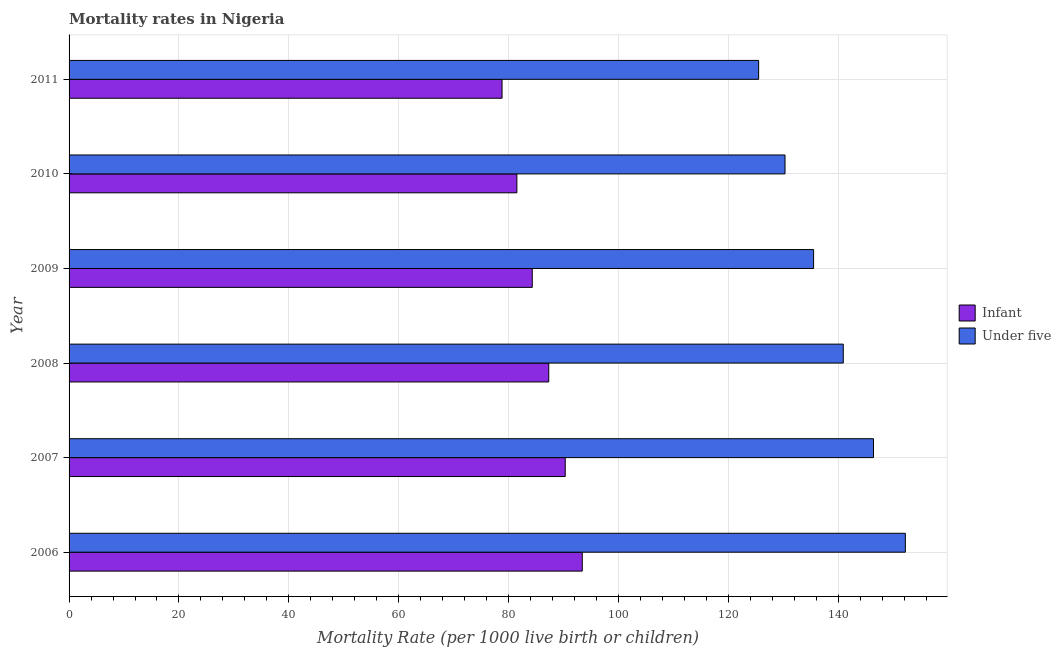How many different coloured bars are there?
Ensure brevity in your answer.  2. Are the number of bars per tick equal to the number of legend labels?
Provide a short and direct response. Yes. How many bars are there on the 1st tick from the top?
Your answer should be compact. 2. How many bars are there on the 4th tick from the bottom?
Offer a very short reply. 2. What is the label of the 6th group of bars from the top?
Ensure brevity in your answer.  2006. What is the infant mortality rate in 2007?
Keep it short and to the point. 90.3. Across all years, what is the maximum under-5 mortality rate?
Your response must be concise. 152.2. Across all years, what is the minimum infant mortality rate?
Make the answer very short. 78.8. What is the total infant mortality rate in the graph?
Your answer should be very brief. 515.6. What is the difference between the under-5 mortality rate in 2008 and that in 2009?
Offer a very short reply. 5.4. What is the difference between the under-5 mortality rate in 2008 and the infant mortality rate in 2011?
Provide a succinct answer. 62.1. What is the average infant mortality rate per year?
Your answer should be compact. 85.93. In the year 2011, what is the difference between the infant mortality rate and under-5 mortality rate?
Your answer should be compact. -46.7. In how many years, is the infant mortality rate greater than 104 ?
Offer a terse response. 0. What is the ratio of the infant mortality rate in 2006 to that in 2008?
Ensure brevity in your answer.  1.07. Is the under-5 mortality rate in 2008 less than that in 2009?
Keep it short and to the point. No. Is the difference between the infant mortality rate in 2006 and 2011 greater than the difference between the under-5 mortality rate in 2006 and 2011?
Offer a very short reply. No. What is the difference between the highest and the second highest infant mortality rate?
Give a very brief answer. 3.1. What is the difference between the highest and the lowest under-5 mortality rate?
Your answer should be very brief. 26.7. In how many years, is the under-5 mortality rate greater than the average under-5 mortality rate taken over all years?
Offer a very short reply. 3. Is the sum of the infant mortality rate in 2009 and 2010 greater than the maximum under-5 mortality rate across all years?
Ensure brevity in your answer.  Yes. What does the 2nd bar from the top in 2008 represents?
Provide a short and direct response. Infant. What does the 2nd bar from the bottom in 2010 represents?
Offer a very short reply. Under five. How many bars are there?
Give a very brief answer. 12. Are all the bars in the graph horizontal?
Your response must be concise. Yes. What is the difference between two consecutive major ticks on the X-axis?
Ensure brevity in your answer.  20. Are the values on the major ticks of X-axis written in scientific E-notation?
Your response must be concise. No. Does the graph contain any zero values?
Offer a very short reply. No. Does the graph contain grids?
Your answer should be very brief. Yes. Where does the legend appear in the graph?
Provide a succinct answer. Center right. How are the legend labels stacked?
Keep it short and to the point. Vertical. What is the title of the graph?
Offer a very short reply. Mortality rates in Nigeria. Does "Commercial bank branches" appear as one of the legend labels in the graph?
Provide a short and direct response. No. What is the label or title of the X-axis?
Ensure brevity in your answer.  Mortality Rate (per 1000 live birth or children). What is the label or title of the Y-axis?
Ensure brevity in your answer.  Year. What is the Mortality Rate (per 1000 live birth or children) in Infant in 2006?
Offer a terse response. 93.4. What is the Mortality Rate (per 1000 live birth or children) in Under five in 2006?
Make the answer very short. 152.2. What is the Mortality Rate (per 1000 live birth or children) of Infant in 2007?
Provide a short and direct response. 90.3. What is the Mortality Rate (per 1000 live birth or children) in Under five in 2007?
Keep it short and to the point. 146.4. What is the Mortality Rate (per 1000 live birth or children) of Infant in 2008?
Give a very brief answer. 87.3. What is the Mortality Rate (per 1000 live birth or children) of Under five in 2008?
Offer a terse response. 140.9. What is the Mortality Rate (per 1000 live birth or children) in Infant in 2009?
Your answer should be very brief. 84.3. What is the Mortality Rate (per 1000 live birth or children) of Under five in 2009?
Give a very brief answer. 135.5. What is the Mortality Rate (per 1000 live birth or children) of Infant in 2010?
Your response must be concise. 81.5. What is the Mortality Rate (per 1000 live birth or children) of Under five in 2010?
Keep it short and to the point. 130.3. What is the Mortality Rate (per 1000 live birth or children) in Infant in 2011?
Provide a succinct answer. 78.8. What is the Mortality Rate (per 1000 live birth or children) in Under five in 2011?
Give a very brief answer. 125.5. Across all years, what is the maximum Mortality Rate (per 1000 live birth or children) of Infant?
Provide a short and direct response. 93.4. Across all years, what is the maximum Mortality Rate (per 1000 live birth or children) of Under five?
Offer a very short reply. 152.2. Across all years, what is the minimum Mortality Rate (per 1000 live birth or children) of Infant?
Your answer should be very brief. 78.8. Across all years, what is the minimum Mortality Rate (per 1000 live birth or children) in Under five?
Your response must be concise. 125.5. What is the total Mortality Rate (per 1000 live birth or children) of Infant in the graph?
Keep it short and to the point. 515.6. What is the total Mortality Rate (per 1000 live birth or children) in Under five in the graph?
Your answer should be very brief. 830.8. What is the difference between the Mortality Rate (per 1000 live birth or children) of Infant in 2006 and that in 2007?
Provide a short and direct response. 3.1. What is the difference between the Mortality Rate (per 1000 live birth or children) in Infant in 2006 and that in 2010?
Your answer should be compact. 11.9. What is the difference between the Mortality Rate (per 1000 live birth or children) in Under five in 2006 and that in 2010?
Offer a terse response. 21.9. What is the difference between the Mortality Rate (per 1000 live birth or children) of Under five in 2006 and that in 2011?
Give a very brief answer. 26.7. What is the difference between the Mortality Rate (per 1000 live birth or children) of Infant in 2007 and that in 2008?
Keep it short and to the point. 3. What is the difference between the Mortality Rate (per 1000 live birth or children) in Under five in 2007 and that in 2008?
Provide a succinct answer. 5.5. What is the difference between the Mortality Rate (per 1000 live birth or children) in Under five in 2007 and that in 2009?
Offer a terse response. 10.9. What is the difference between the Mortality Rate (per 1000 live birth or children) in Infant in 2007 and that in 2010?
Make the answer very short. 8.8. What is the difference between the Mortality Rate (per 1000 live birth or children) in Under five in 2007 and that in 2010?
Provide a succinct answer. 16.1. What is the difference between the Mortality Rate (per 1000 live birth or children) in Infant in 2007 and that in 2011?
Offer a terse response. 11.5. What is the difference between the Mortality Rate (per 1000 live birth or children) in Under five in 2007 and that in 2011?
Make the answer very short. 20.9. What is the difference between the Mortality Rate (per 1000 live birth or children) of Infant in 2008 and that in 2009?
Make the answer very short. 3. What is the difference between the Mortality Rate (per 1000 live birth or children) in Under five in 2008 and that in 2009?
Your response must be concise. 5.4. What is the difference between the Mortality Rate (per 1000 live birth or children) in Infant in 2008 and that in 2011?
Your response must be concise. 8.5. What is the difference between the Mortality Rate (per 1000 live birth or children) of Under five in 2009 and that in 2010?
Make the answer very short. 5.2. What is the difference between the Mortality Rate (per 1000 live birth or children) in Under five in 2009 and that in 2011?
Give a very brief answer. 10. What is the difference between the Mortality Rate (per 1000 live birth or children) of Infant in 2006 and the Mortality Rate (per 1000 live birth or children) of Under five in 2007?
Offer a very short reply. -53. What is the difference between the Mortality Rate (per 1000 live birth or children) of Infant in 2006 and the Mortality Rate (per 1000 live birth or children) of Under five in 2008?
Offer a terse response. -47.5. What is the difference between the Mortality Rate (per 1000 live birth or children) in Infant in 2006 and the Mortality Rate (per 1000 live birth or children) in Under five in 2009?
Ensure brevity in your answer.  -42.1. What is the difference between the Mortality Rate (per 1000 live birth or children) in Infant in 2006 and the Mortality Rate (per 1000 live birth or children) in Under five in 2010?
Your answer should be very brief. -36.9. What is the difference between the Mortality Rate (per 1000 live birth or children) of Infant in 2006 and the Mortality Rate (per 1000 live birth or children) of Under five in 2011?
Keep it short and to the point. -32.1. What is the difference between the Mortality Rate (per 1000 live birth or children) in Infant in 2007 and the Mortality Rate (per 1000 live birth or children) in Under five in 2008?
Make the answer very short. -50.6. What is the difference between the Mortality Rate (per 1000 live birth or children) of Infant in 2007 and the Mortality Rate (per 1000 live birth or children) of Under five in 2009?
Give a very brief answer. -45.2. What is the difference between the Mortality Rate (per 1000 live birth or children) in Infant in 2007 and the Mortality Rate (per 1000 live birth or children) in Under five in 2010?
Provide a succinct answer. -40. What is the difference between the Mortality Rate (per 1000 live birth or children) in Infant in 2007 and the Mortality Rate (per 1000 live birth or children) in Under five in 2011?
Keep it short and to the point. -35.2. What is the difference between the Mortality Rate (per 1000 live birth or children) of Infant in 2008 and the Mortality Rate (per 1000 live birth or children) of Under five in 2009?
Your answer should be compact. -48.2. What is the difference between the Mortality Rate (per 1000 live birth or children) in Infant in 2008 and the Mortality Rate (per 1000 live birth or children) in Under five in 2010?
Provide a succinct answer. -43. What is the difference between the Mortality Rate (per 1000 live birth or children) in Infant in 2008 and the Mortality Rate (per 1000 live birth or children) in Under five in 2011?
Provide a short and direct response. -38.2. What is the difference between the Mortality Rate (per 1000 live birth or children) in Infant in 2009 and the Mortality Rate (per 1000 live birth or children) in Under five in 2010?
Your answer should be compact. -46. What is the difference between the Mortality Rate (per 1000 live birth or children) of Infant in 2009 and the Mortality Rate (per 1000 live birth or children) of Under five in 2011?
Offer a terse response. -41.2. What is the difference between the Mortality Rate (per 1000 live birth or children) of Infant in 2010 and the Mortality Rate (per 1000 live birth or children) of Under five in 2011?
Your answer should be very brief. -44. What is the average Mortality Rate (per 1000 live birth or children) of Infant per year?
Your answer should be very brief. 85.93. What is the average Mortality Rate (per 1000 live birth or children) of Under five per year?
Provide a short and direct response. 138.47. In the year 2006, what is the difference between the Mortality Rate (per 1000 live birth or children) of Infant and Mortality Rate (per 1000 live birth or children) of Under five?
Offer a terse response. -58.8. In the year 2007, what is the difference between the Mortality Rate (per 1000 live birth or children) of Infant and Mortality Rate (per 1000 live birth or children) of Under five?
Offer a terse response. -56.1. In the year 2008, what is the difference between the Mortality Rate (per 1000 live birth or children) of Infant and Mortality Rate (per 1000 live birth or children) of Under five?
Give a very brief answer. -53.6. In the year 2009, what is the difference between the Mortality Rate (per 1000 live birth or children) of Infant and Mortality Rate (per 1000 live birth or children) of Under five?
Give a very brief answer. -51.2. In the year 2010, what is the difference between the Mortality Rate (per 1000 live birth or children) in Infant and Mortality Rate (per 1000 live birth or children) in Under five?
Offer a terse response. -48.8. In the year 2011, what is the difference between the Mortality Rate (per 1000 live birth or children) of Infant and Mortality Rate (per 1000 live birth or children) of Under five?
Offer a very short reply. -46.7. What is the ratio of the Mortality Rate (per 1000 live birth or children) in Infant in 2006 to that in 2007?
Your answer should be very brief. 1.03. What is the ratio of the Mortality Rate (per 1000 live birth or children) in Under five in 2006 to that in 2007?
Ensure brevity in your answer.  1.04. What is the ratio of the Mortality Rate (per 1000 live birth or children) of Infant in 2006 to that in 2008?
Offer a very short reply. 1.07. What is the ratio of the Mortality Rate (per 1000 live birth or children) of Under five in 2006 to that in 2008?
Your response must be concise. 1.08. What is the ratio of the Mortality Rate (per 1000 live birth or children) of Infant in 2006 to that in 2009?
Your answer should be compact. 1.11. What is the ratio of the Mortality Rate (per 1000 live birth or children) in Under five in 2006 to that in 2009?
Provide a succinct answer. 1.12. What is the ratio of the Mortality Rate (per 1000 live birth or children) of Infant in 2006 to that in 2010?
Keep it short and to the point. 1.15. What is the ratio of the Mortality Rate (per 1000 live birth or children) of Under five in 2006 to that in 2010?
Provide a short and direct response. 1.17. What is the ratio of the Mortality Rate (per 1000 live birth or children) of Infant in 2006 to that in 2011?
Your answer should be compact. 1.19. What is the ratio of the Mortality Rate (per 1000 live birth or children) in Under five in 2006 to that in 2011?
Offer a terse response. 1.21. What is the ratio of the Mortality Rate (per 1000 live birth or children) of Infant in 2007 to that in 2008?
Ensure brevity in your answer.  1.03. What is the ratio of the Mortality Rate (per 1000 live birth or children) of Under five in 2007 to that in 2008?
Offer a very short reply. 1.04. What is the ratio of the Mortality Rate (per 1000 live birth or children) of Infant in 2007 to that in 2009?
Your answer should be compact. 1.07. What is the ratio of the Mortality Rate (per 1000 live birth or children) in Under five in 2007 to that in 2009?
Your answer should be compact. 1.08. What is the ratio of the Mortality Rate (per 1000 live birth or children) of Infant in 2007 to that in 2010?
Provide a succinct answer. 1.11. What is the ratio of the Mortality Rate (per 1000 live birth or children) of Under five in 2007 to that in 2010?
Your answer should be compact. 1.12. What is the ratio of the Mortality Rate (per 1000 live birth or children) in Infant in 2007 to that in 2011?
Offer a terse response. 1.15. What is the ratio of the Mortality Rate (per 1000 live birth or children) in Under five in 2007 to that in 2011?
Your response must be concise. 1.17. What is the ratio of the Mortality Rate (per 1000 live birth or children) in Infant in 2008 to that in 2009?
Offer a terse response. 1.04. What is the ratio of the Mortality Rate (per 1000 live birth or children) of Under five in 2008 to that in 2009?
Offer a terse response. 1.04. What is the ratio of the Mortality Rate (per 1000 live birth or children) of Infant in 2008 to that in 2010?
Offer a very short reply. 1.07. What is the ratio of the Mortality Rate (per 1000 live birth or children) of Under five in 2008 to that in 2010?
Provide a short and direct response. 1.08. What is the ratio of the Mortality Rate (per 1000 live birth or children) of Infant in 2008 to that in 2011?
Your answer should be compact. 1.11. What is the ratio of the Mortality Rate (per 1000 live birth or children) of Under five in 2008 to that in 2011?
Offer a terse response. 1.12. What is the ratio of the Mortality Rate (per 1000 live birth or children) of Infant in 2009 to that in 2010?
Provide a succinct answer. 1.03. What is the ratio of the Mortality Rate (per 1000 live birth or children) of Under five in 2009 to that in 2010?
Provide a short and direct response. 1.04. What is the ratio of the Mortality Rate (per 1000 live birth or children) in Infant in 2009 to that in 2011?
Give a very brief answer. 1.07. What is the ratio of the Mortality Rate (per 1000 live birth or children) in Under five in 2009 to that in 2011?
Your response must be concise. 1.08. What is the ratio of the Mortality Rate (per 1000 live birth or children) of Infant in 2010 to that in 2011?
Make the answer very short. 1.03. What is the ratio of the Mortality Rate (per 1000 live birth or children) in Under five in 2010 to that in 2011?
Provide a succinct answer. 1.04. What is the difference between the highest and the second highest Mortality Rate (per 1000 live birth or children) in Infant?
Your response must be concise. 3.1. What is the difference between the highest and the lowest Mortality Rate (per 1000 live birth or children) in Infant?
Your answer should be compact. 14.6. What is the difference between the highest and the lowest Mortality Rate (per 1000 live birth or children) in Under five?
Offer a terse response. 26.7. 